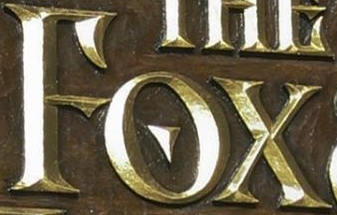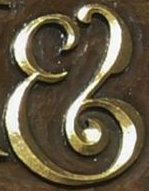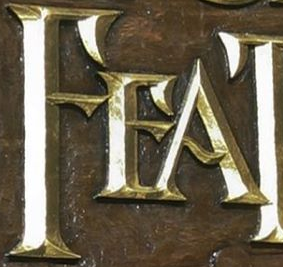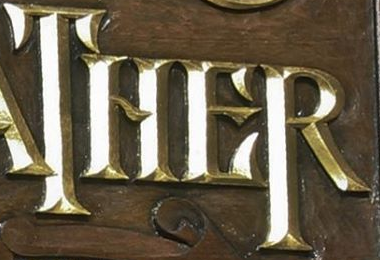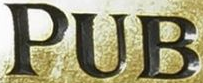Read the text from these images in sequence, separated by a semicolon. FOX; &; FEA; THER; PUB 